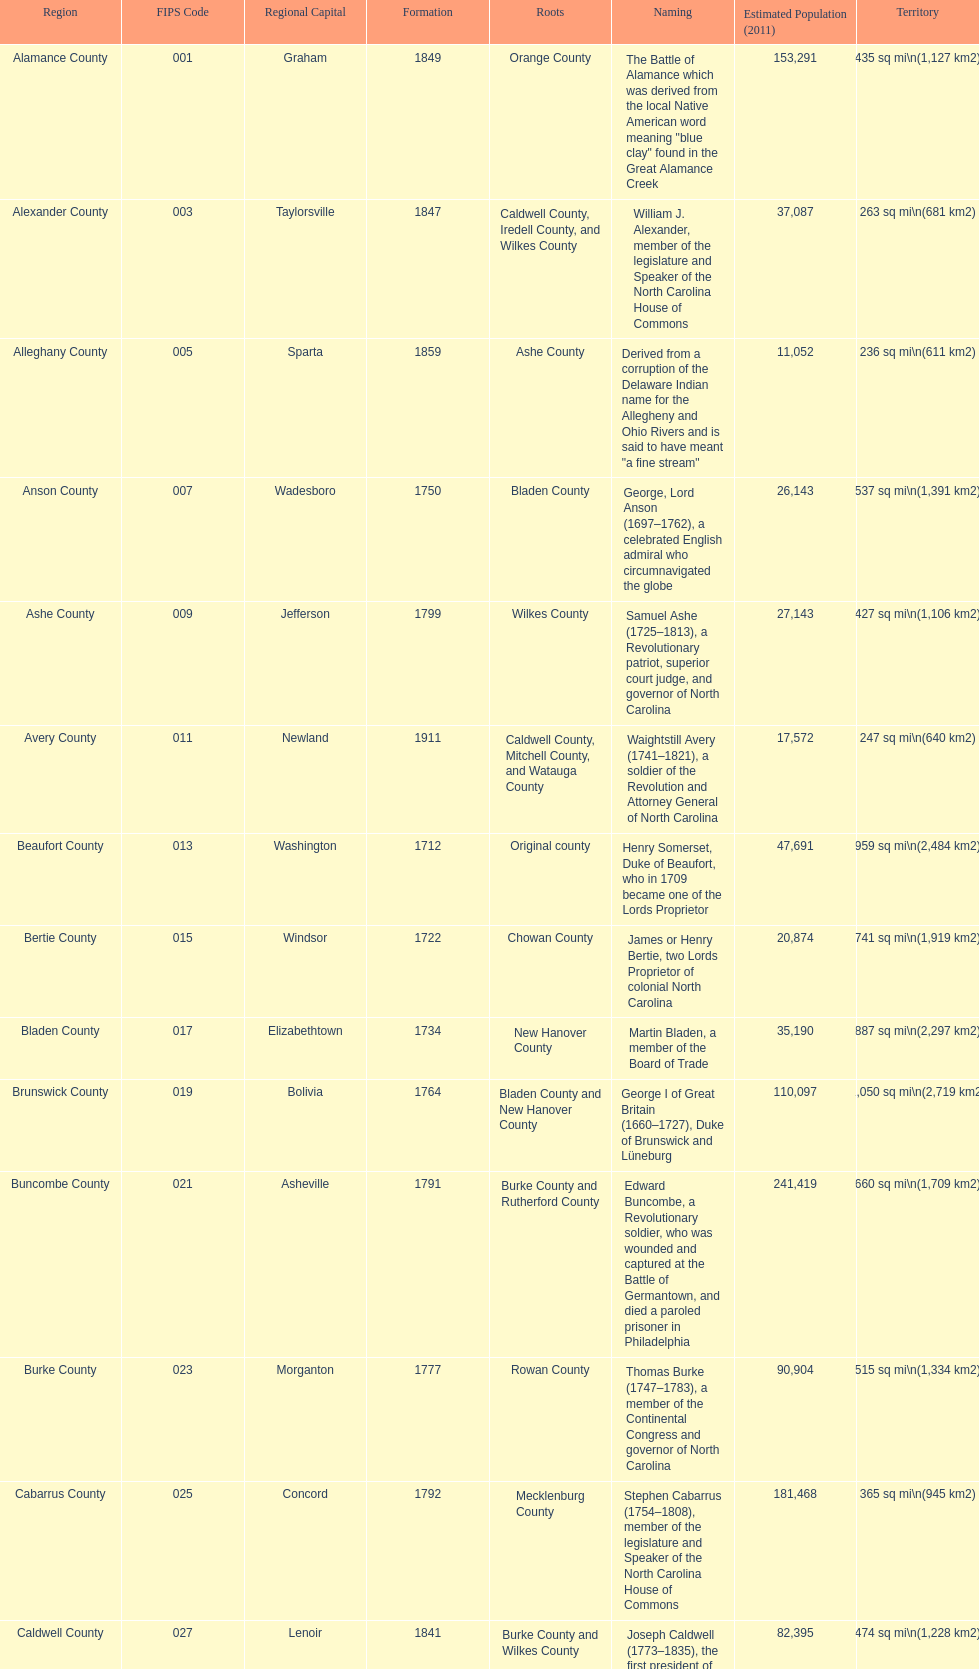Which county occupies the most extensive area? Dare County. 